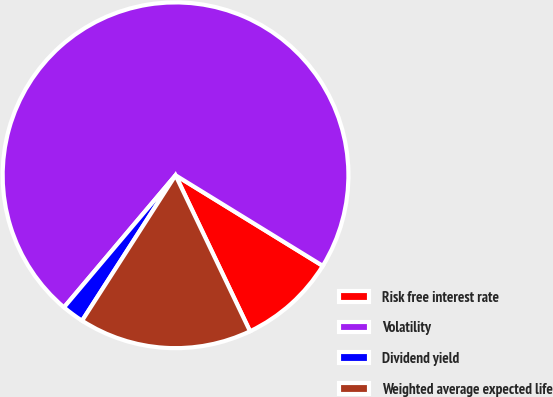Convert chart. <chart><loc_0><loc_0><loc_500><loc_500><pie_chart><fcel>Risk free interest rate<fcel>Volatility<fcel>Dividend yield<fcel>Weighted average expected life<nl><fcel>9.13%<fcel>72.61%<fcel>2.07%<fcel>16.18%<nl></chart> 